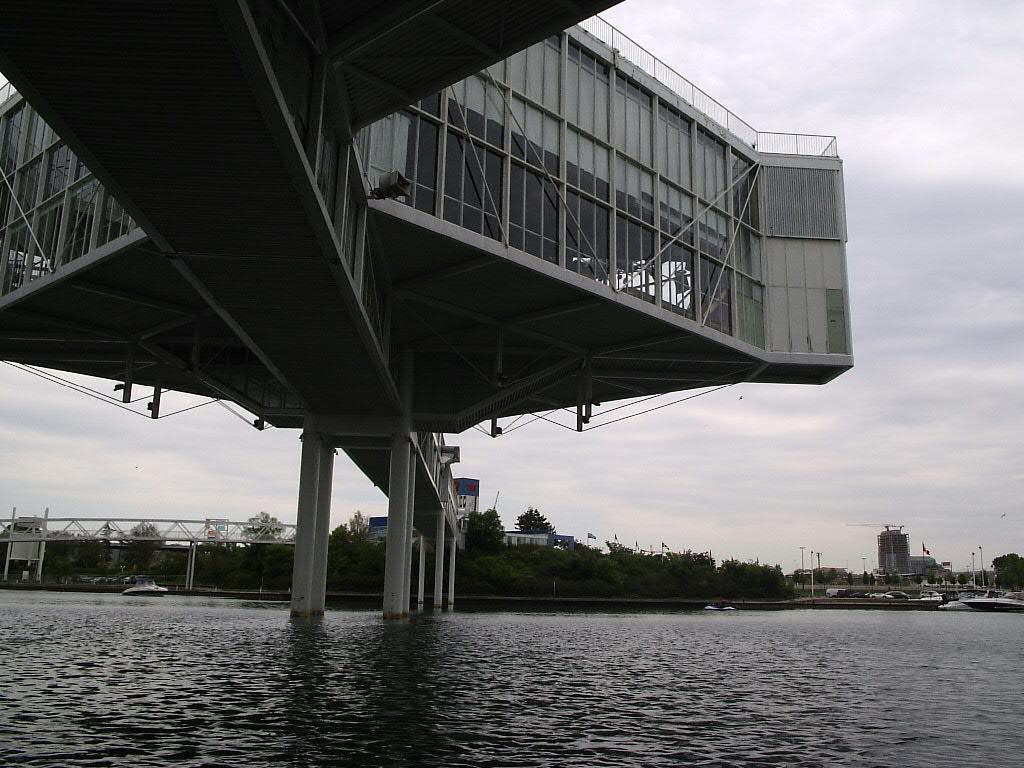Describe this image in one or two sentences. In this image we can see a sea. There is a cloudy sky in the image. There are many trees in the image. There is a bridge in the image. There are few water crafts in the image. There are many poles in the image. 